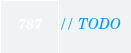Convert code to text. <code><loc_0><loc_0><loc_500><loc_500><_C++_>
// TODO
</code> 